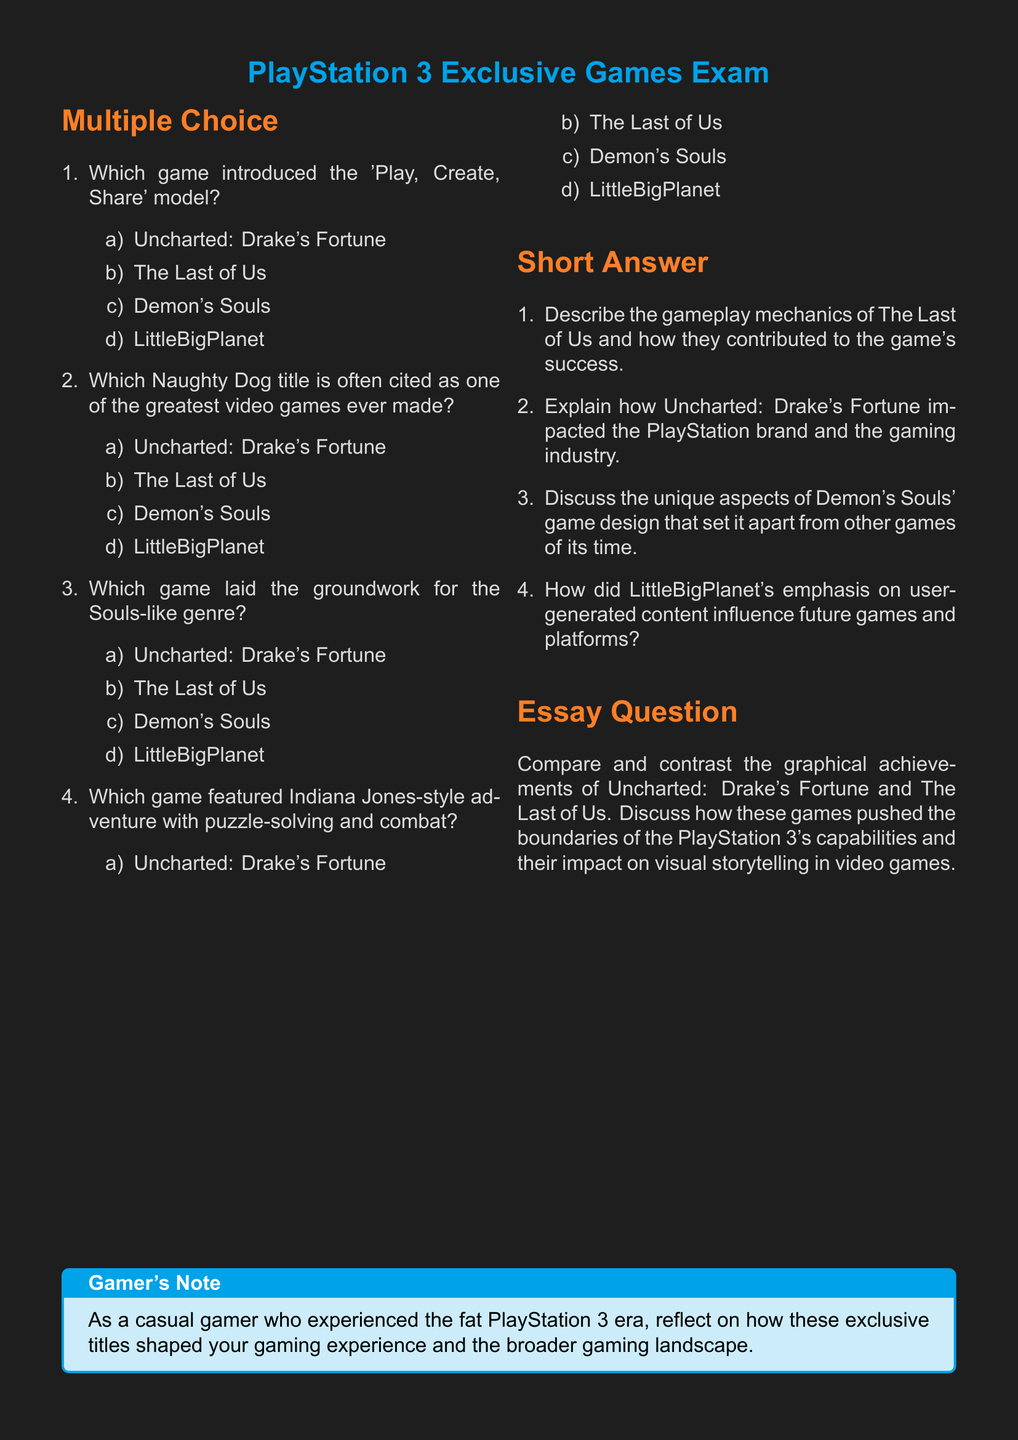What game introduced the 'Play, Create, Share' model? The question refers to the title that is associated with the 'Play, Create, Share' model in the multiple choice section of the exam.
Answer: LittleBigPlanet Which Naughty Dog title is cited as one of the greatest video games ever made? This question asks for a specific title from the list provided in the exam that is noted for its acclaim, particularly by Naughty Dog.
Answer: The Last of Us What game laid the groundwork for the Souls-like genre? The question seeks the game that has been recognized for starting the Souls-like genre, as mentioned in the exam.
Answer: Demon's Souls Which game features Indiana Jones-style adventure? The question targets the game that combines puzzle-solving, combat, and adventure, indicated in the multiple choice section.
Answer: Uncharted: Drake's Fortune How many sections are in the exam? The document contains distinct sections including multiple choice, short answer, and an essay question, which can be counted.
Answer: Three 